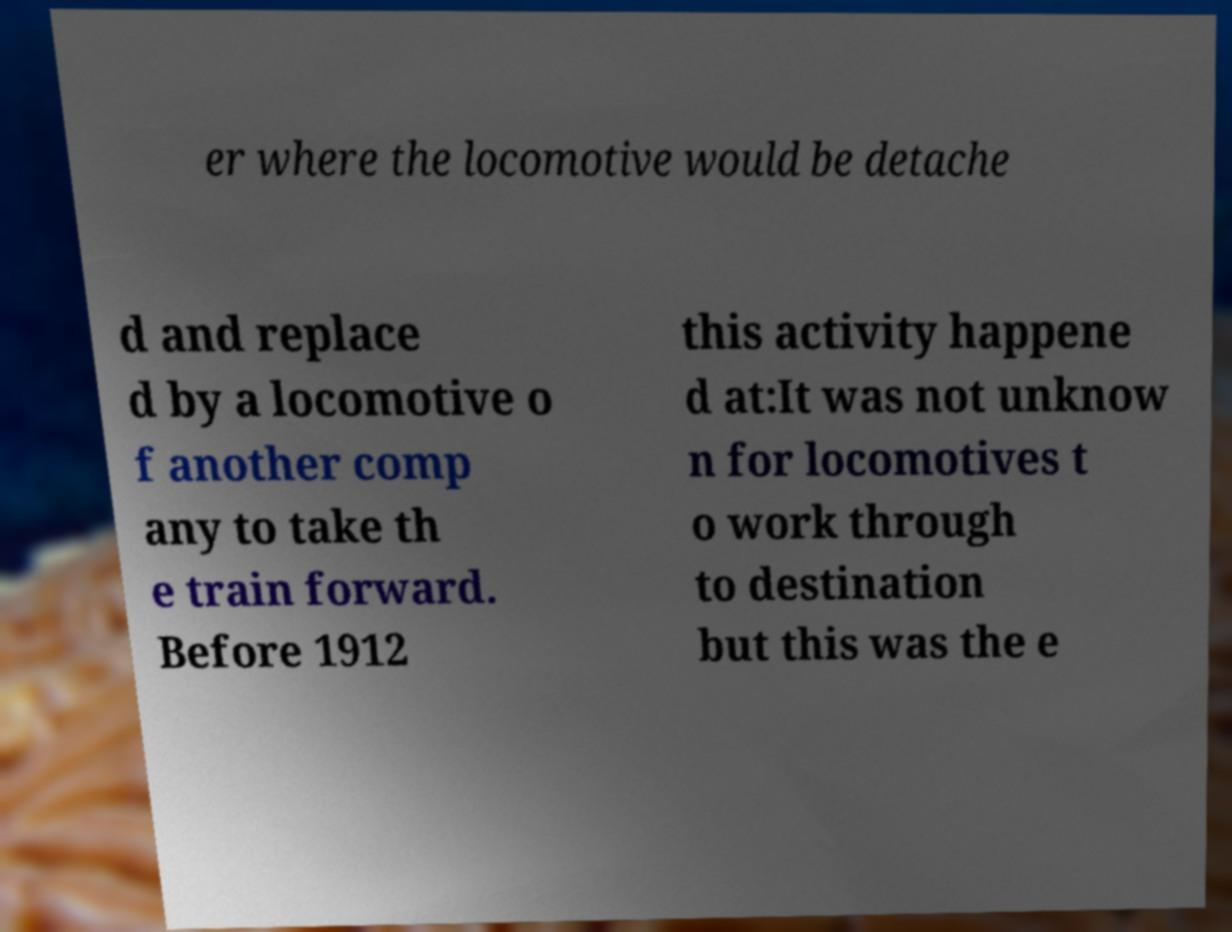For documentation purposes, I need the text within this image transcribed. Could you provide that? er where the locomotive would be detache d and replace d by a locomotive o f another comp any to take th e train forward. Before 1912 this activity happene d at:It was not unknow n for locomotives t o work through to destination but this was the e 